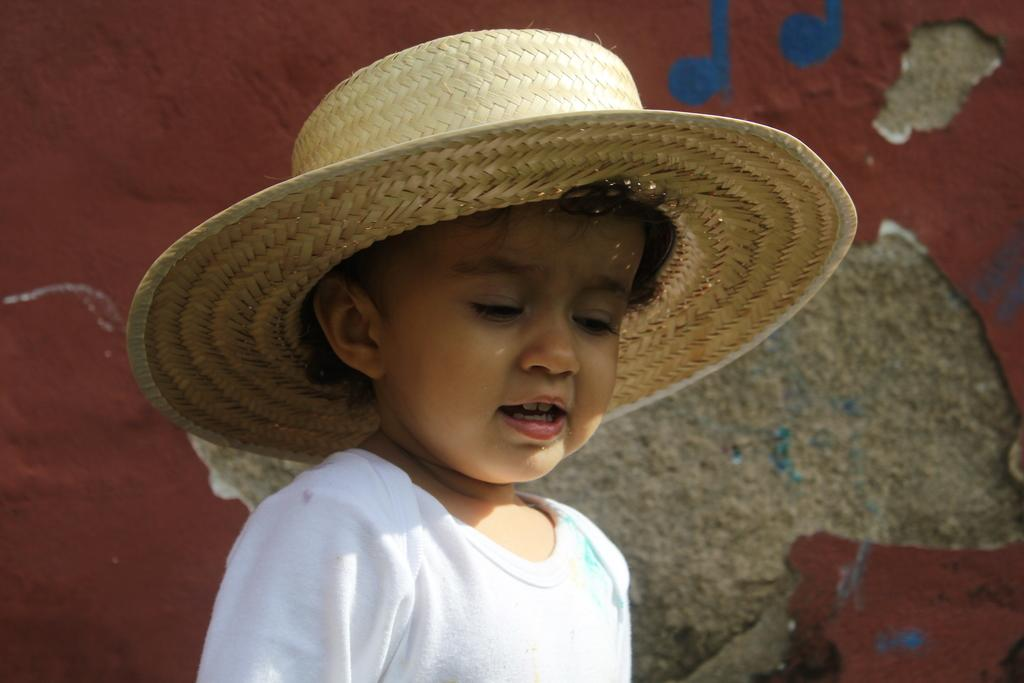What is the main subject of the image? The main subject of the image is a kid. What is the kid wearing in the image? The kid is wearing a hat in the image. What can be seen in the background of the image? There is a wall in the background of the image. What is on the wall in the image? There is a red colored object and some art visible on the wall. How many hands can be seen holding the art on the wall in the image? There are no hands visible in the image, as the focus is on the kid and the wall. 